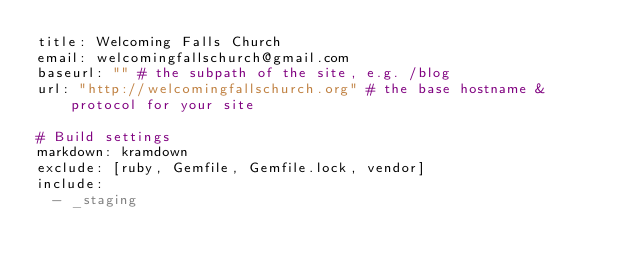Convert code to text. <code><loc_0><loc_0><loc_500><loc_500><_YAML_>title: Welcoming Falls Church
email: welcomingfallschurch@gmail.com
baseurl: "" # the subpath of the site, e.g. /blog
url: "http://welcomingfallschurch.org" # the base hostname & protocol for your site

# Build settings
markdown: kramdown
exclude: [ruby, Gemfile, Gemfile.lock, vendor]
include:
  - _staging</code> 